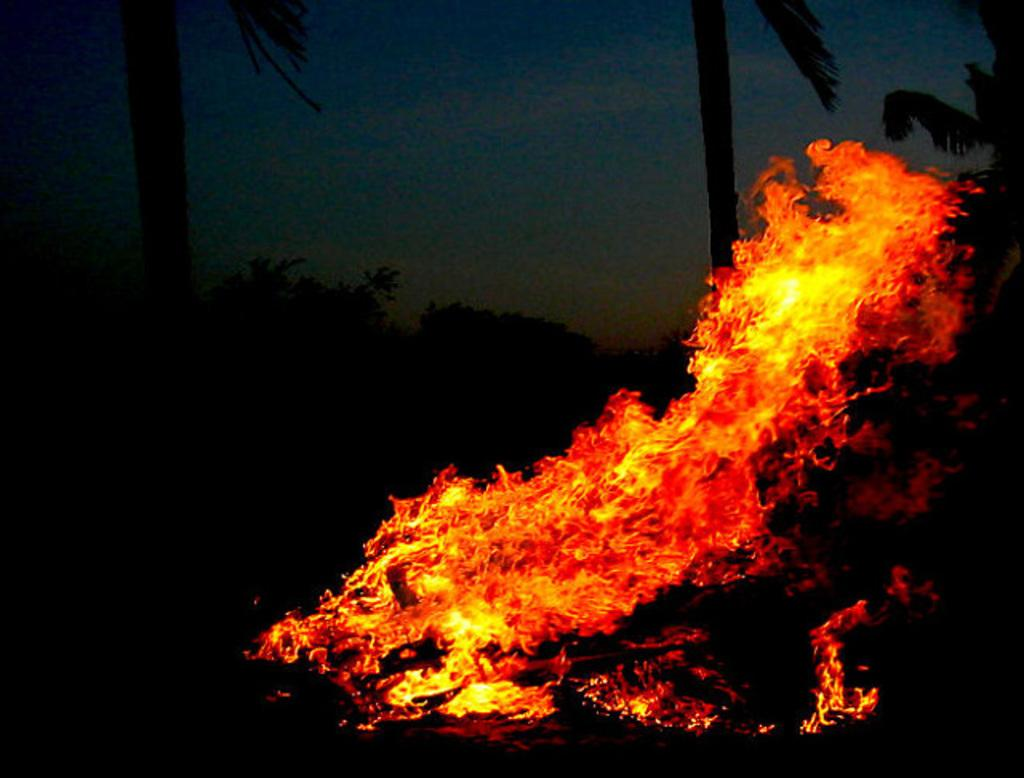What is the primary element in the image? There is fire in the image. What type of natural elements can be seen in the image? There are trees in the image. What can be seen in the background of the image? The sky is visible in the background of the image. What type of brush is being used to apply oil to the trees in the image? There is no brush or oil present in the image; it features fire and trees. 